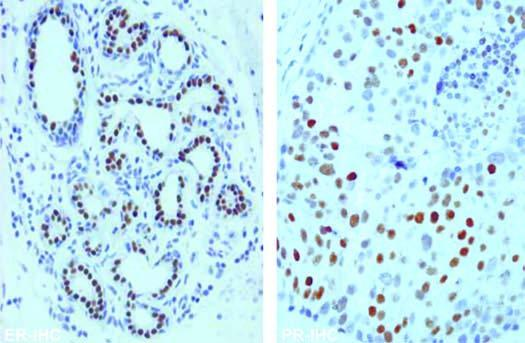do the tumour cells show nuclear positivity with er and pr antibody immunostains?
Answer the question using a single word or phrase. Yes 